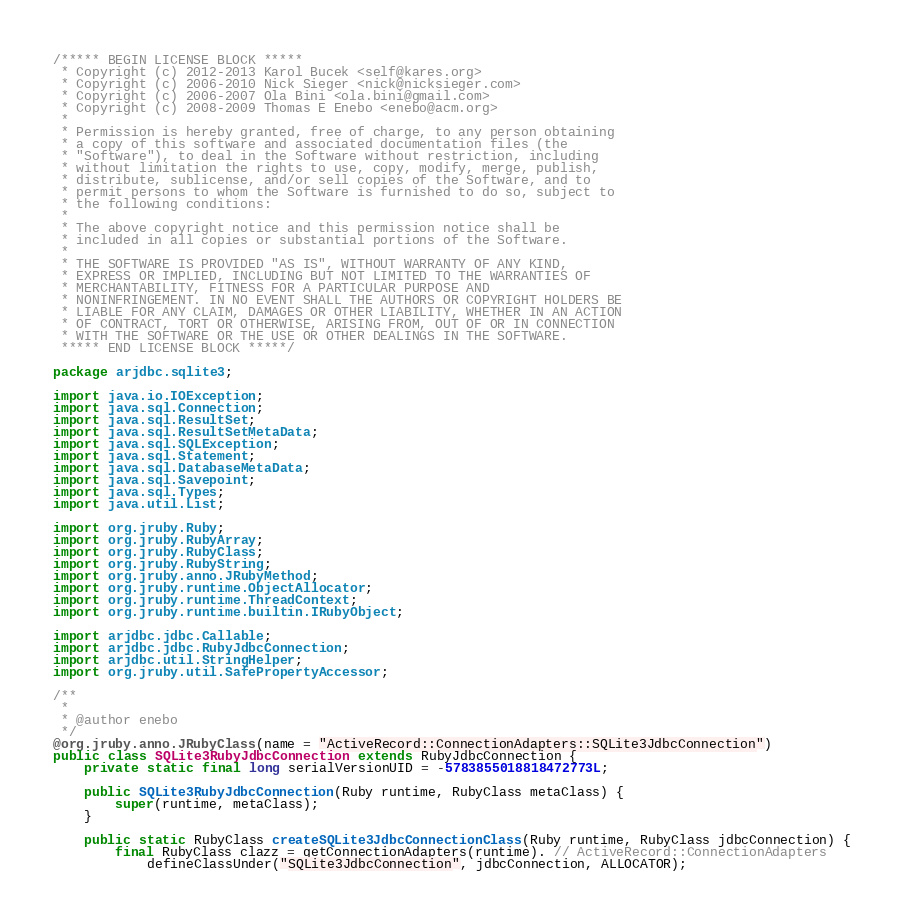Convert code to text. <code><loc_0><loc_0><loc_500><loc_500><_Java_>/***** BEGIN LICENSE BLOCK *****
 * Copyright (c) 2012-2013 Karol Bucek <self@kares.org>
 * Copyright (c) 2006-2010 Nick Sieger <nick@nicksieger.com>
 * Copyright (c) 2006-2007 Ola Bini <ola.bini@gmail.com>
 * Copyright (c) 2008-2009 Thomas E Enebo <enebo@acm.org>
 *
 * Permission is hereby granted, free of charge, to any person obtaining
 * a copy of this software and associated documentation files (the
 * "Software"), to deal in the Software without restriction, including
 * without limitation the rights to use, copy, modify, merge, publish,
 * distribute, sublicense, and/or sell copies of the Software, and to
 * permit persons to whom the Software is furnished to do so, subject to
 * the following conditions:
 *
 * The above copyright notice and this permission notice shall be
 * included in all copies or substantial portions of the Software.
 *
 * THE SOFTWARE IS PROVIDED "AS IS", WITHOUT WARRANTY OF ANY KIND,
 * EXPRESS OR IMPLIED, INCLUDING BUT NOT LIMITED TO THE WARRANTIES OF
 * MERCHANTABILITY, FITNESS FOR A PARTICULAR PURPOSE AND
 * NONINFRINGEMENT. IN NO EVENT SHALL THE AUTHORS OR COPYRIGHT HOLDERS BE
 * LIABLE FOR ANY CLAIM, DAMAGES OR OTHER LIABILITY, WHETHER IN AN ACTION
 * OF CONTRACT, TORT OR OTHERWISE, ARISING FROM, OUT OF OR IN CONNECTION
 * WITH THE SOFTWARE OR THE USE OR OTHER DEALINGS IN THE SOFTWARE.
 ***** END LICENSE BLOCK *****/

package arjdbc.sqlite3;

import java.io.IOException;
import java.sql.Connection;
import java.sql.ResultSet;
import java.sql.ResultSetMetaData;
import java.sql.SQLException;
import java.sql.Statement;
import java.sql.DatabaseMetaData;
import java.sql.Savepoint;
import java.sql.Types;
import java.util.List;

import org.jruby.Ruby;
import org.jruby.RubyArray;
import org.jruby.RubyClass;
import org.jruby.RubyString;
import org.jruby.anno.JRubyMethod;
import org.jruby.runtime.ObjectAllocator;
import org.jruby.runtime.ThreadContext;
import org.jruby.runtime.builtin.IRubyObject;

import arjdbc.jdbc.Callable;
import arjdbc.jdbc.RubyJdbcConnection;
import arjdbc.util.StringHelper;
import org.jruby.util.SafePropertyAccessor;

/**
 *
 * @author enebo
 */
@org.jruby.anno.JRubyClass(name = "ActiveRecord::ConnectionAdapters::SQLite3JdbcConnection")
public class SQLite3RubyJdbcConnection extends RubyJdbcConnection {
    private static final long serialVersionUID = -5783855018818472773L;

    public SQLite3RubyJdbcConnection(Ruby runtime, RubyClass metaClass) {
        super(runtime, metaClass);
    }

    public static RubyClass createSQLite3JdbcConnectionClass(Ruby runtime, RubyClass jdbcConnection) {
        final RubyClass clazz = getConnectionAdapters(runtime). // ActiveRecord::ConnectionAdapters
            defineClassUnder("SQLite3JdbcConnection", jdbcConnection, ALLOCATOR);</code> 